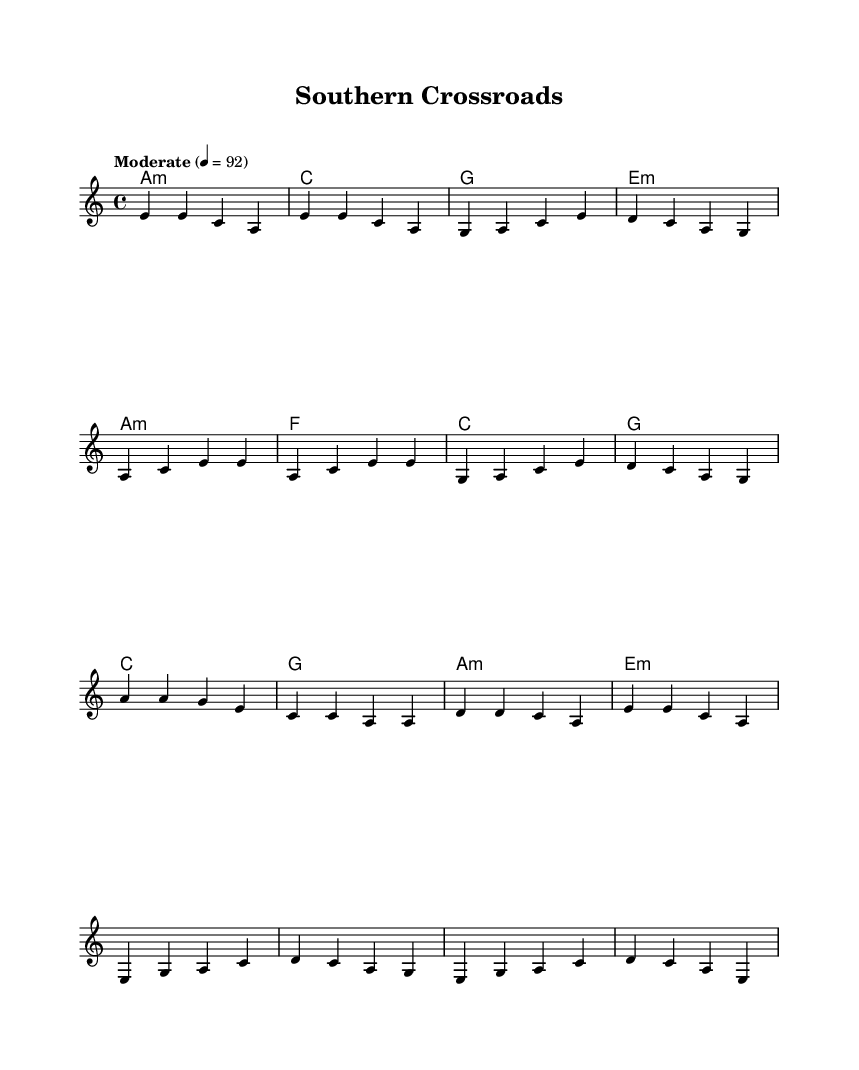What is the key signature of this music? The key signature is A minor, which has no sharps or flats, indicated by the absence of any accidentals in the key signature section.
Answer: A minor What is the time signature of this music? The time signature is 4/4, meaning there are four beats in each measure, as shown at the beginning of the sheet music.
Answer: 4/4 What is the tempo marking indicated for the piece? The tempo marking is "Moderate" with a metronome marking of 92 beats per minute, noted above the staff.
Answer: Moderate 4 = 92 What chords are used in the chorus section? The chords in the chorus section are A minor, F, C, and G based on the chord symbols placed above the melody line.
Answer: A minor, F, C, G How many measures are in the verse section? The verse section contains four measures, as counted from the melody line. Each measure is clearly divided by vertical bar lines.
Answer: 4 What is the first note in the melody? The first note in the melody is E, which is indicated at the start of the melody staff in the relative pitch notation.
Answer: E What type of music fusion does this piece represent? This piece represents a country-blues fusion, evident from its stylistic elements that reflect both genres' characteristics and roots in the American South.
Answer: Country-blues fusion 